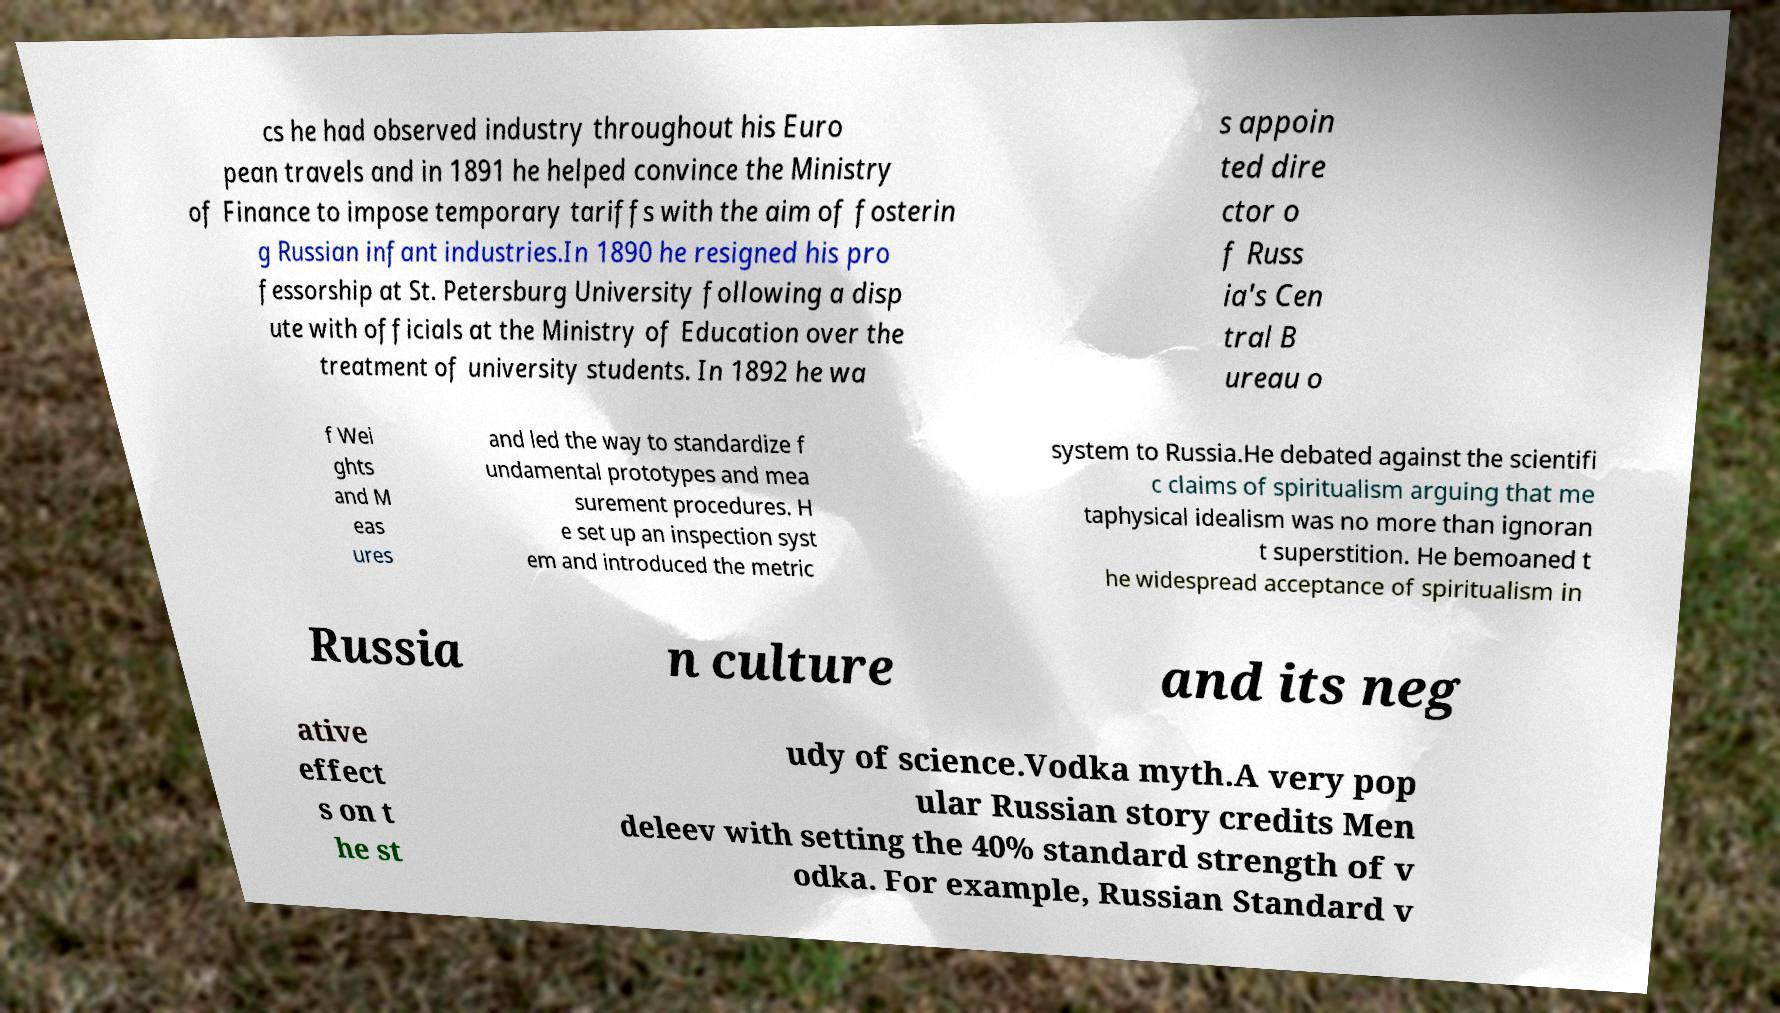Can you accurately transcribe the text from the provided image for me? cs he had observed industry throughout his Euro pean travels and in 1891 he helped convince the Ministry of Finance to impose temporary tariffs with the aim of fosterin g Russian infant industries.In 1890 he resigned his pro fessorship at St. Petersburg University following a disp ute with officials at the Ministry of Education over the treatment of university students. In 1892 he wa s appoin ted dire ctor o f Russ ia's Cen tral B ureau o f Wei ghts and M eas ures and led the way to standardize f undamental prototypes and mea surement procedures. H e set up an inspection syst em and introduced the metric system to Russia.He debated against the scientifi c claims of spiritualism arguing that me taphysical idealism was no more than ignoran t superstition. He bemoaned t he widespread acceptance of spiritualism in Russia n culture and its neg ative effect s on t he st udy of science.Vodka myth.A very pop ular Russian story credits Men deleev with setting the 40% standard strength of v odka. For example, Russian Standard v 